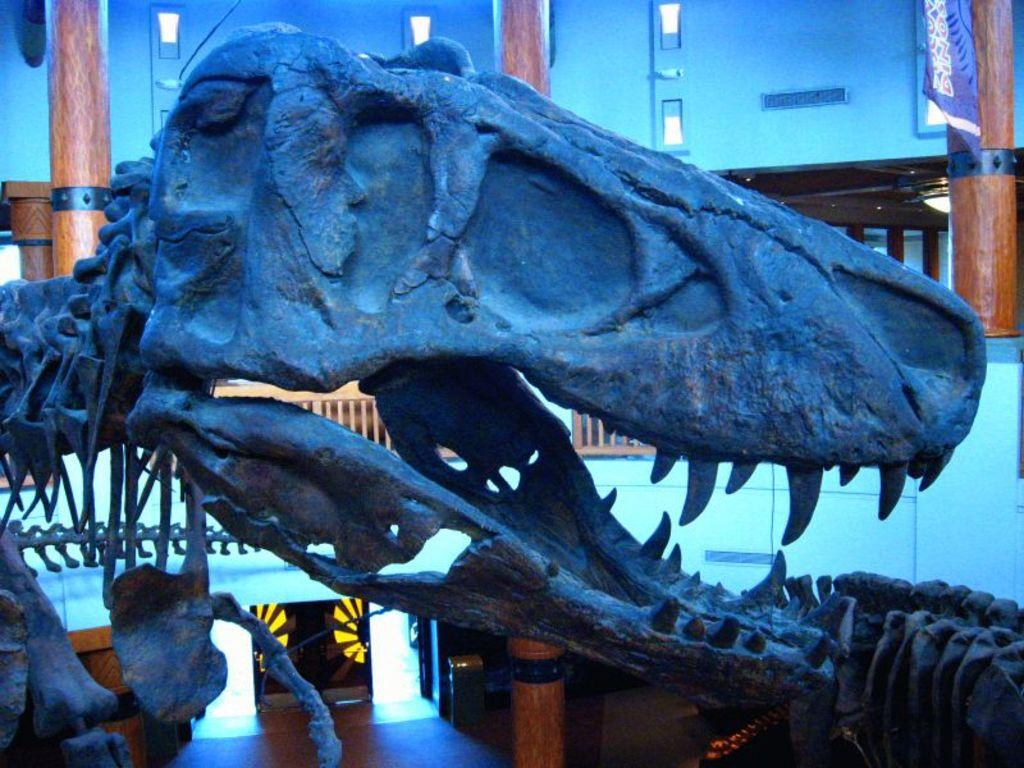What is the main subject of the picture? The main subject of the picture is a dinosaur skull. Where is the picture taken? The image is an inside view of a building. What can be seen in the background of the picture? There is a wall in the background of the picture. What is located at the right top of the picture? There is a cloth at the right top of the picture. Can you hear the bells ringing in the picture? There are no bells present in the image, so it is not possible to hear them ringing. 